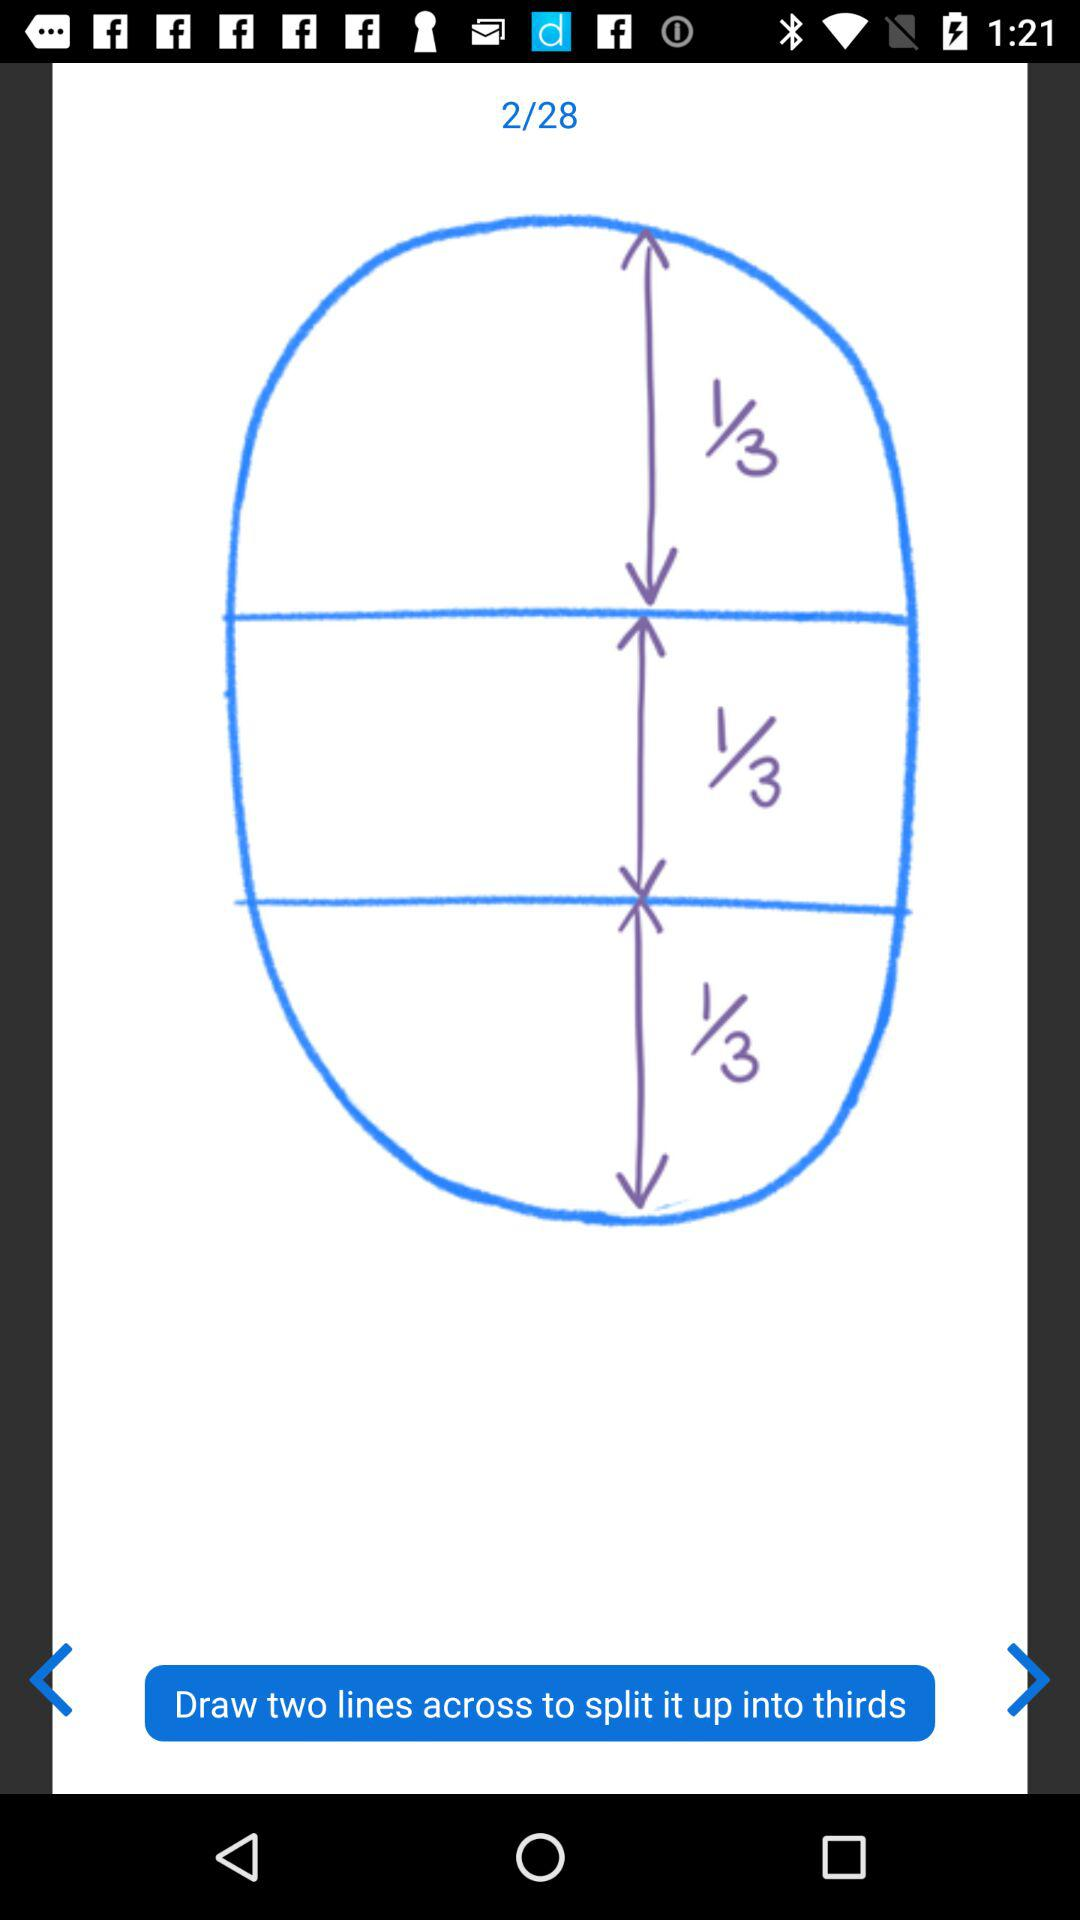What page number am I on? You are on page 2. 